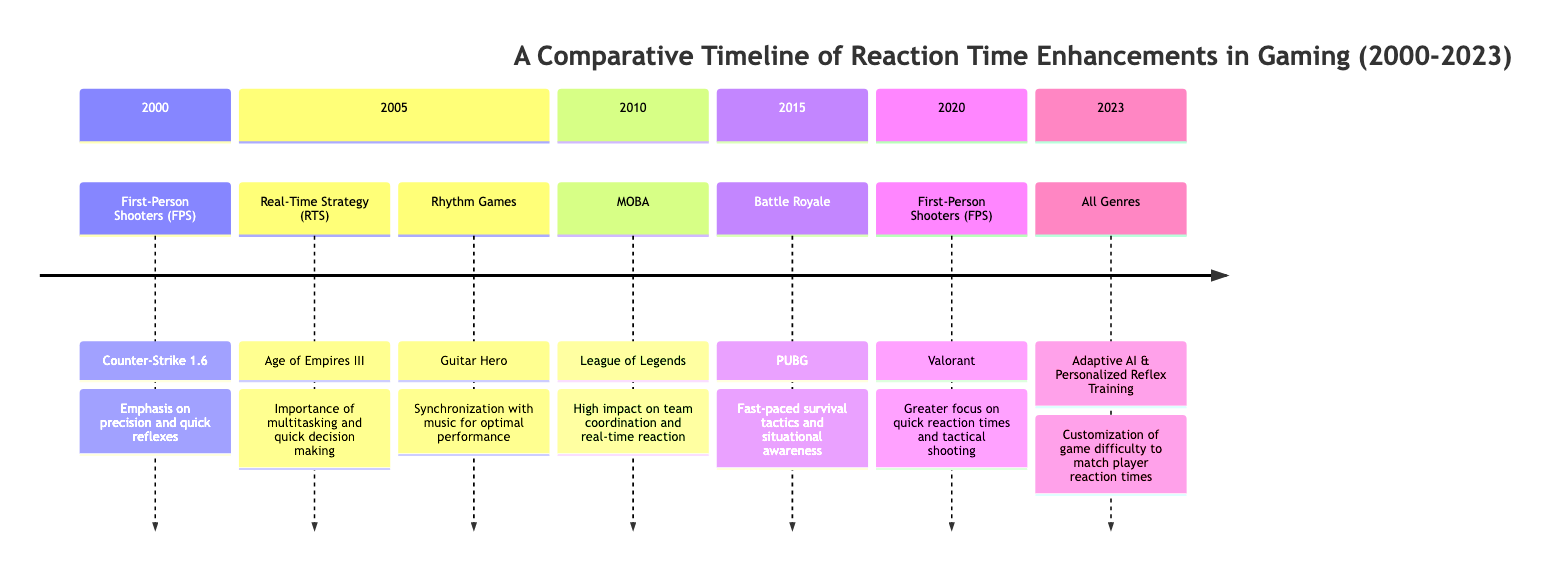What genre had an emphasis on quick reflexes in 2000? The diagram specifies that in 2000, the genre of First-Person Shooters (FPS) had an emphasis on precision and quick reflexes, which is illustrated next to the key event "Counter-Strike 1.6."
Answer: First-Person Shooters (FPS) Which game was released in 2005 that focused on multitasking? According to the timeline, the game "Age of Empires III" was launched in 2005 and is associated with Real-Time Strategy (RTS), highlighting the importance of multitasking and quick decision making.
Answer: Age of Empires III What significant event took place in the MOBA genre in 2010? The timeline indicates that in 2010, the key event for the MOBA genre was the rise of "League of Legends,” which had a high impact on team coordination and real-time reaction.
Answer: League of Legends How did PlayerUnknown's Battlegrounds affect player performance in 2015? The diagram states that PlayerUnknown's Battlegrounds (PUBG) introduced important fast-paced survival tactics and situational awareness in 2015, enhancing player performance through environmental scanning and rapid engagement.
Answer: Enhanced through environmental scanning and rapid engagement What integration occurred in 2023 across all genres? The timeline mentions that in 2023, there was a key event related to the integration of Adaptive AI and Personalized Reflex Training Tools, customizing game difficulty to match player reaction times.
Answer: Integration of Adaptive AI and Personalized Reflex Training Tools What type of enhancement was emphasized in Valorant's launch in 2020? The diagram highlights that with the launch of Valorant in 2020, there was a greater focus on quick reaction times and tactical shooting, indicating an emphasis on precision aiming and reflex sharpness.
Answer: Quick reaction times and tactical shooting Which genre saw the most significant emphasis on synchronization with music in 2005? The timeline indicates that in 2005, the Rhythm Games genre, represented by "Guitar Hero," emphasized synchronization with music for optimal performance.
Answer: Rhythm Games How did player performance change with the introduction of Adaptive AI in 2023? The timeline specifies that the integration of Adaptive AI and Personalized Reflex Training Tools in 2023 led to substantial enhancement in player performance via AI-driven reflex analysis and training modules.
Answer: Substantial enhancement via AI-driven reflex analysis and training modules 